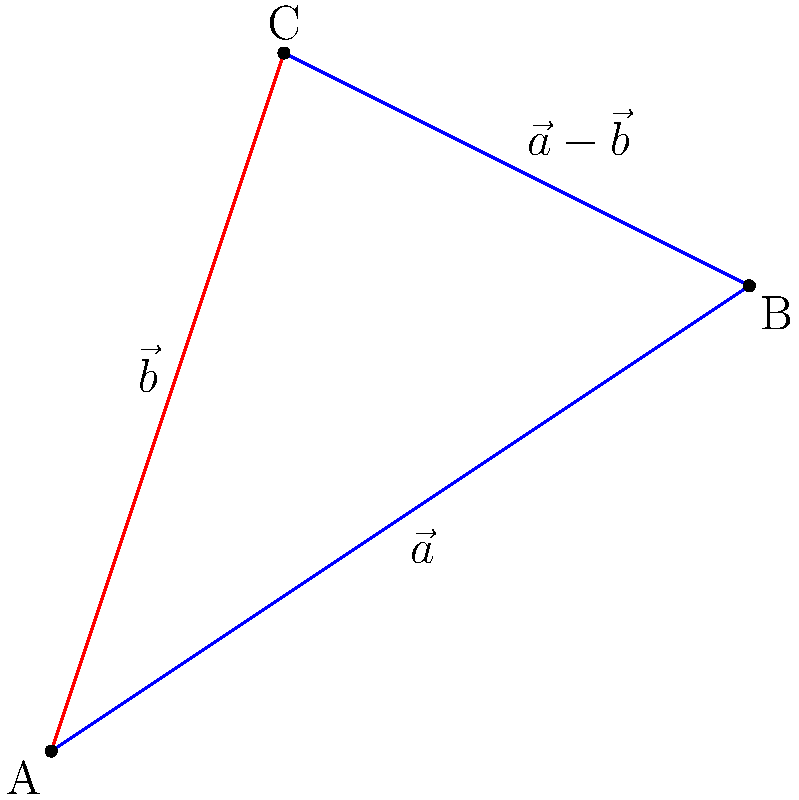In this minimalist geometric composition, vectors $\vec{a}$ and $\vec{b}$ are represented by the blue sides of the triangle. The red line represents the vector subtraction $\vec{a} - \vec{b}$. How does this visual representation challenge or support the surrealist interpretation of vector operations? Explain your answer in terms of the geometric forms present. To understand this representation, let's break it down step-by-step:

1. Vector $\vec{a}$ is represented by the blue line from A to B.
2. Vector $\vec{b}$ is represented by the blue line from A to C.
3. The red line from C to B represents the vector subtraction $\vec{a} - \vec{b}$.

This representation challenges surrealist interpretation in several ways:

1. Minimalism: The use of simple geometric forms (a triangle) to represent complex mathematical operations is inherently minimalist, contrasting with surrealist tendencies towards elaborate or dream-like imagery.

2. Literal representation: Vector subtraction is visually represented as the direct path between the endpoints of the two vectors, which is a literal, concrete interpretation rather than a surreal one.

3. Closure: The triangle formed by the vectors creates a closed shape, which can be seen as a complete thought or concept, contrary to surrealist open-ended or ambiguous representations.

However, it also supports surrealist interpretation:

1. Unexpected connections: The red line (result) connects two points that were not originally connected, creating an unexpected relationship.

2. Transformation: The subtraction operation transforms two vectors into a new vector, aligning with surrealist ideas of metamorphosis.

3. Multiple perspectives: The same triangle can be interpreted as representing different vector operations depending on which lines are focused on, allowing for multiple simultaneous truths.

This minimalist representation thus creates a tension between concrete mathematical concepts and the potential for surrealist interpretation, challenging the viewer to reconcile these seemingly opposing approaches to visual representation.
Answer: Minimalist form creates tension between concrete math and surreal interpretation. 